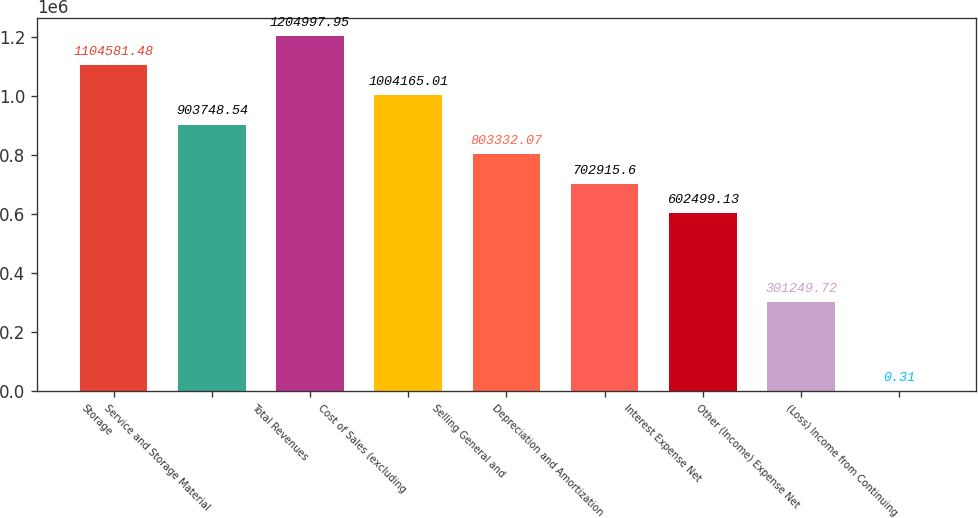Convert chart to OTSL. <chart><loc_0><loc_0><loc_500><loc_500><bar_chart><fcel>Storage<fcel>Service and Storage Material<fcel>Total Revenues<fcel>Cost of Sales (excluding<fcel>Selling General and<fcel>Depreciation and Amortization<fcel>Interest Expense Net<fcel>Other (Income) Expense Net<fcel>(Loss) Income from Continuing<nl><fcel>1.10458e+06<fcel>903749<fcel>1.205e+06<fcel>1.00417e+06<fcel>803332<fcel>702916<fcel>602499<fcel>301250<fcel>0.31<nl></chart> 